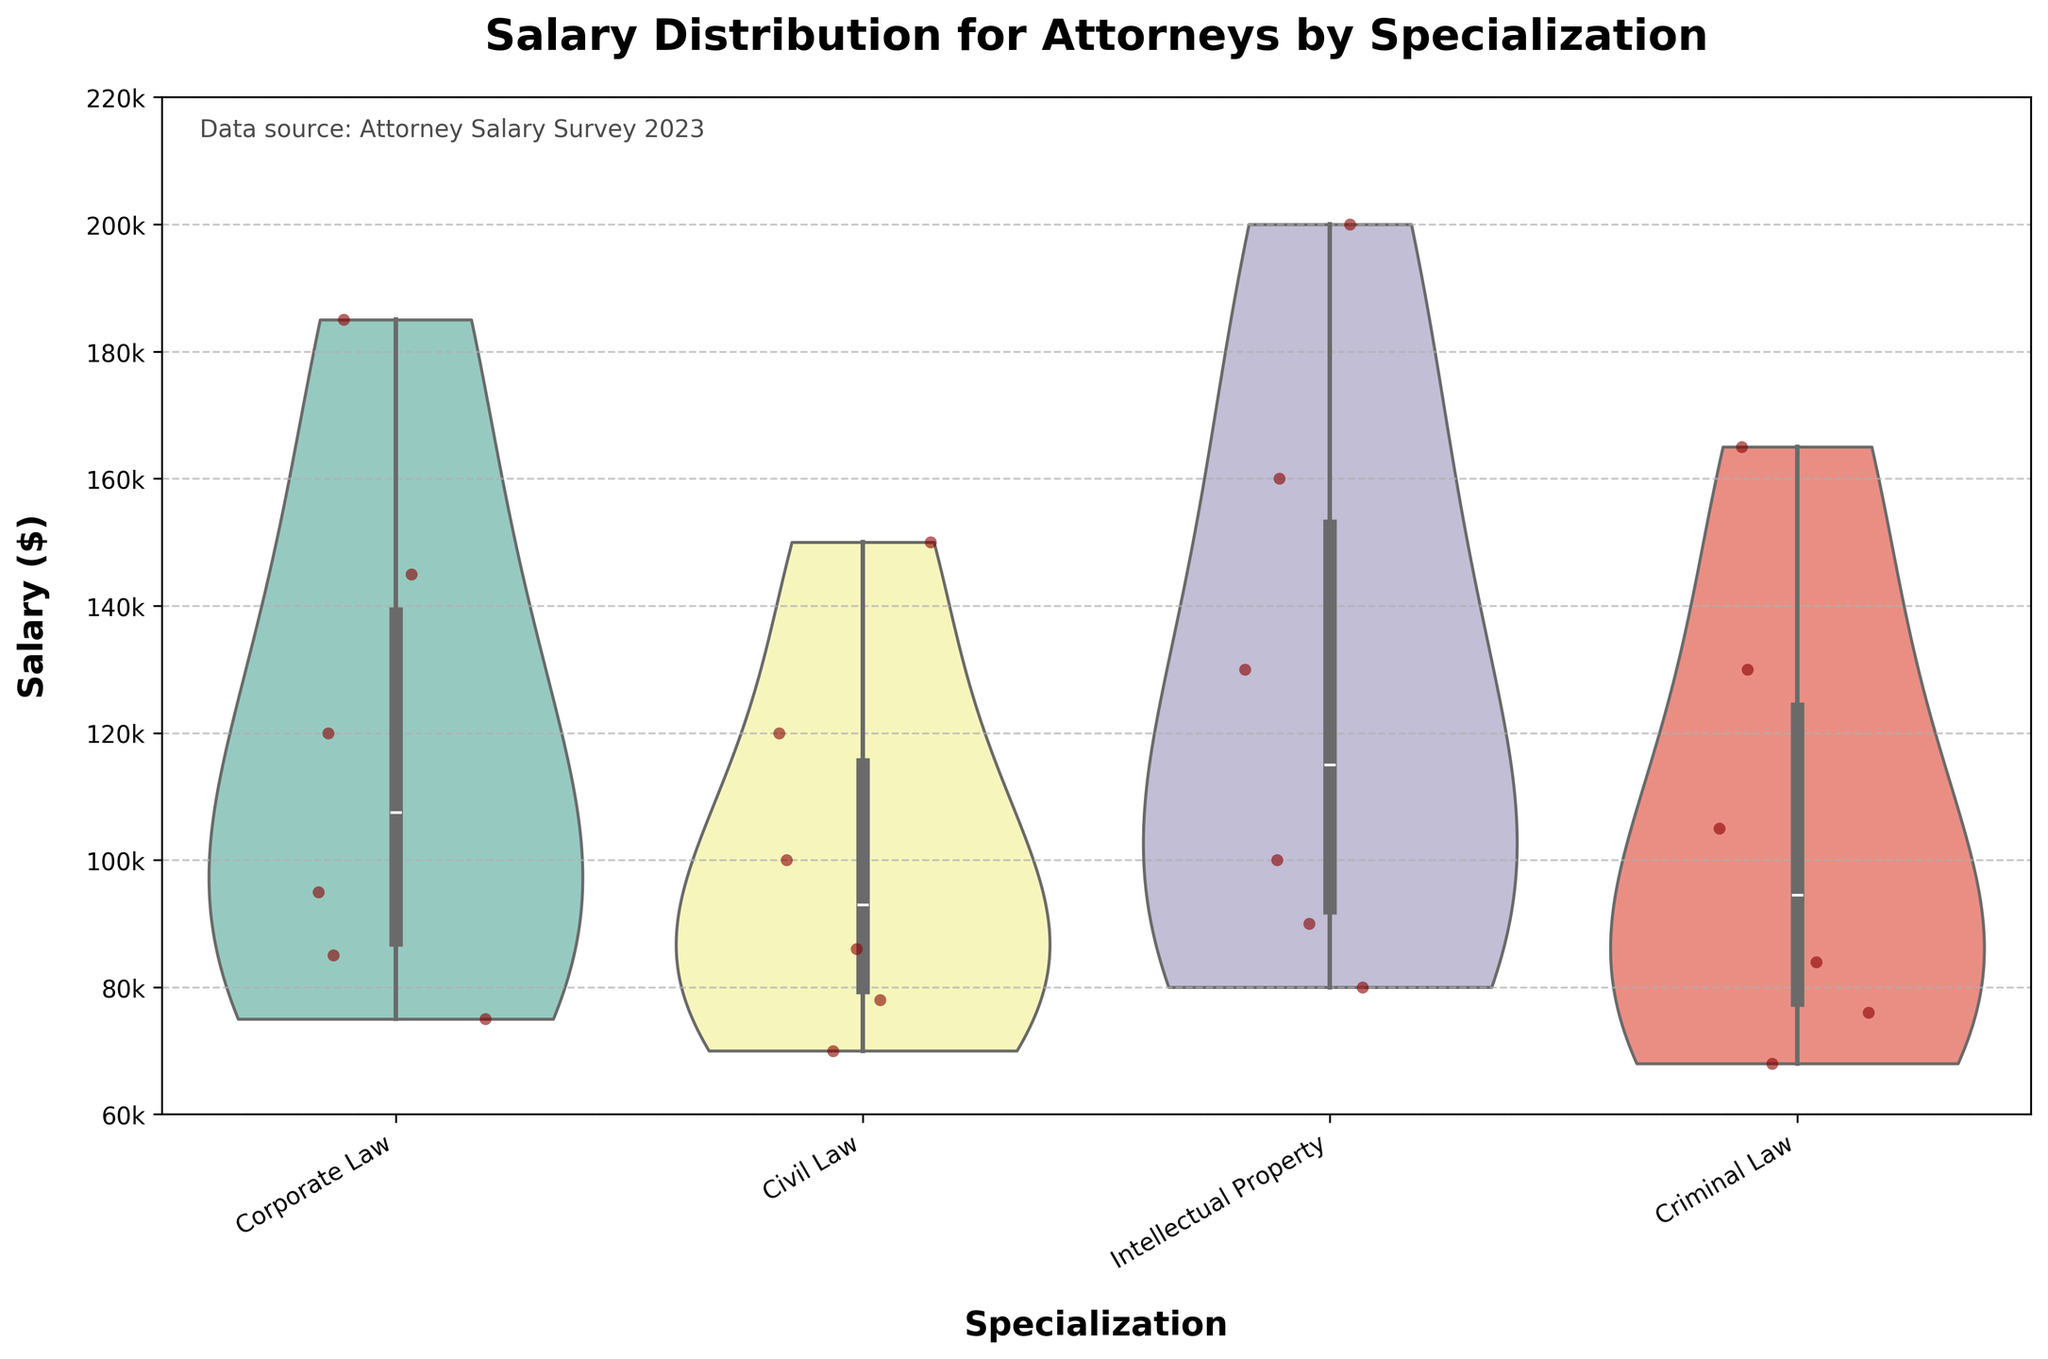What is the title of the plot? The title is found at the top of the figure. It summarizes the content and purpose of the plot.
Answer: Salary Distribution for Attorneys by Specialization How many specializations are compared in the plot? Count the unique labels on the x-axis to determine the number of categories compared.
Answer: 4 What is the range of the salary axis? Observe the y-axis to find the minimum and maximum salary values shown in the plot.
Answer: $60,000 to $220,000 Which specialization has the most spread in salary distribution? Examine the width and length of the violins for each specialization. The wider and longer the violin, the more spread in distribution it has.
Answer: Corporate Law In which specialization is the highest jittered point found? Identify the highest individual point within the spread of each specialization's violin plot.
Answer: Intellectual Property What is the lowest salary recorded in Civil Law specialization? Find the bottom-most point in the violin plot and jittered points for Civil Law.
Answer: $70,000 Is the median salary higher for Criminal Law or Civil Law? Compare the white lines within the violins, which indicate the median salaries, for both specializations.
Answer: Criminal Law What is the average salary for attorneys with 2 years of experience across all specializations? Look for the jittered points corresponding to 2 years of experience within each specialization and average their salaries. Calculate: (2 ✕ 85000 + 78000 + 90000 + 76000) / 4 =  82,750
Answer: $82,750 Which specialization shows the most consistent salary increase with years of experience? Examine the positioning of jittered points and the shape of the violins. The specialization with points consistently moving upward with years and a steep, narrow violin shape is most consistent.
Answer: Intellectual Property How does the salary distribution for Intellectual Property compare to Corporate Law at 7 years of experience? Analyze the vertical positioning and spread of the jittered points and violins for both specializations at 7 years. Assess their relative position and spread.
Answer: Intellectual Property has higher salaries and a broader spread 